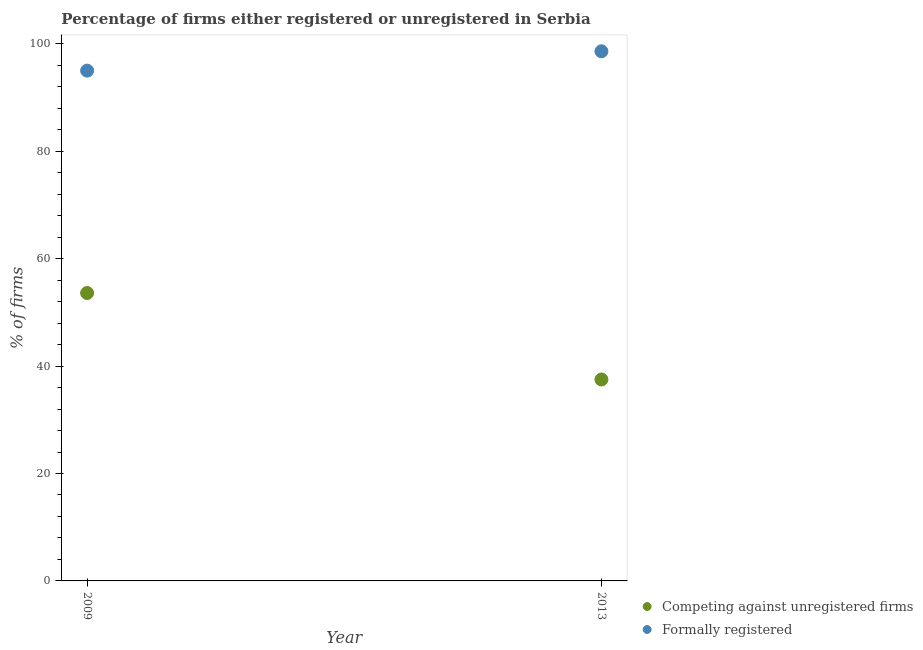How many different coloured dotlines are there?
Your answer should be compact. 2. What is the percentage of registered firms in 2013?
Provide a short and direct response. 37.5. Across all years, what is the maximum percentage of registered firms?
Give a very brief answer. 53.6. What is the total percentage of registered firms in the graph?
Your answer should be compact. 91.1. What is the difference between the percentage of formally registered firms in 2009 and that in 2013?
Your answer should be very brief. -3.6. What is the difference between the percentage of registered firms in 2013 and the percentage of formally registered firms in 2009?
Your response must be concise. -57.5. What is the average percentage of registered firms per year?
Your answer should be compact. 45.55. In the year 2013, what is the difference between the percentage of formally registered firms and percentage of registered firms?
Your response must be concise. 61.1. In how many years, is the percentage of formally registered firms greater than 12 %?
Your response must be concise. 2. What is the ratio of the percentage of formally registered firms in 2009 to that in 2013?
Give a very brief answer. 0.96. Does the percentage of registered firms monotonically increase over the years?
Ensure brevity in your answer.  No. How many dotlines are there?
Your answer should be compact. 2. How many years are there in the graph?
Make the answer very short. 2. Are the values on the major ticks of Y-axis written in scientific E-notation?
Your answer should be compact. No. Does the graph contain any zero values?
Provide a succinct answer. No. Does the graph contain grids?
Make the answer very short. No. Where does the legend appear in the graph?
Offer a terse response. Bottom right. How are the legend labels stacked?
Your answer should be compact. Vertical. What is the title of the graph?
Provide a short and direct response. Percentage of firms either registered or unregistered in Serbia. Does "Primary income" appear as one of the legend labels in the graph?
Keep it short and to the point. No. What is the label or title of the Y-axis?
Ensure brevity in your answer.  % of firms. What is the % of firms of Competing against unregistered firms in 2009?
Your answer should be compact. 53.6. What is the % of firms in Formally registered in 2009?
Offer a very short reply. 95. What is the % of firms of Competing against unregistered firms in 2013?
Make the answer very short. 37.5. What is the % of firms in Formally registered in 2013?
Your response must be concise. 98.6. Across all years, what is the maximum % of firms of Competing against unregistered firms?
Offer a very short reply. 53.6. Across all years, what is the maximum % of firms in Formally registered?
Keep it short and to the point. 98.6. Across all years, what is the minimum % of firms in Competing against unregistered firms?
Your answer should be very brief. 37.5. What is the total % of firms in Competing against unregistered firms in the graph?
Offer a terse response. 91.1. What is the total % of firms of Formally registered in the graph?
Give a very brief answer. 193.6. What is the difference between the % of firms of Competing against unregistered firms in 2009 and the % of firms of Formally registered in 2013?
Offer a terse response. -45. What is the average % of firms of Competing against unregistered firms per year?
Offer a terse response. 45.55. What is the average % of firms of Formally registered per year?
Provide a succinct answer. 96.8. In the year 2009, what is the difference between the % of firms of Competing against unregistered firms and % of firms of Formally registered?
Your answer should be very brief. -41.4. In the year 2013, what is the difference between the % of firms of Competing against unregistered firms and % of firms of Formally registered?
Your answer should be compact. -61.1. What is the ratio of the % of firms of Competing against unregistered firms in 2009 to that in 2013?
Keep it short and to the point. 1.43. What is the ratio of the % of firms in Formally registered in 2009 to that in 2013?
Your answer should be very brief. 0.96. What is the difference between the highest and the second highest % of firms in Competing against unregistered firms?
Offer a very short reply. 16.1. What is the difference between the highest and the lowest % of firms of Competing against unregistered firms?
Provide a short and direct response. 16.1. What is the difference between the highest and the lowest % of firms of Formally registered?
Your answer should be very brief. 3.6. 